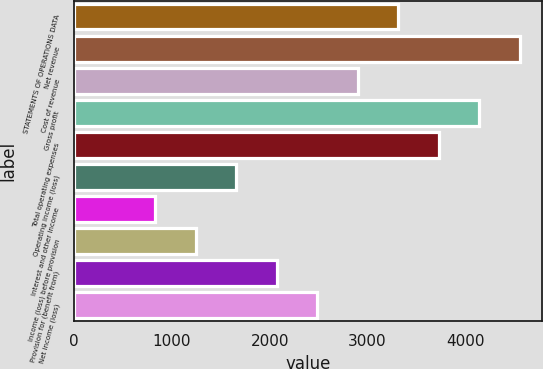Convert chart. <chart><loc_0><loc_0><loc_500><loc_500><bar_chart><fcel>STATEMENTS OF OPERATIONS DATA<fcel>Net revenue<fcel>Cost of revenue<fcel>Gross profit<fcel>Total operating expenses<fcel>Operating income (loss)<fcel>Interest and other income<fcel>Income (loss) before provision<fcel>Provision for (benefit from)<fcel>Net income (loss)<nl><fcel>3314.47<fcel>4557.31<fcel>2900.19<fcel>4143.03<fcel>3728.75<fcel>1657.35<fcel>828.79<fcel>1243.07<fcel>2071.63<fcel>2485.91<nl></chart> 